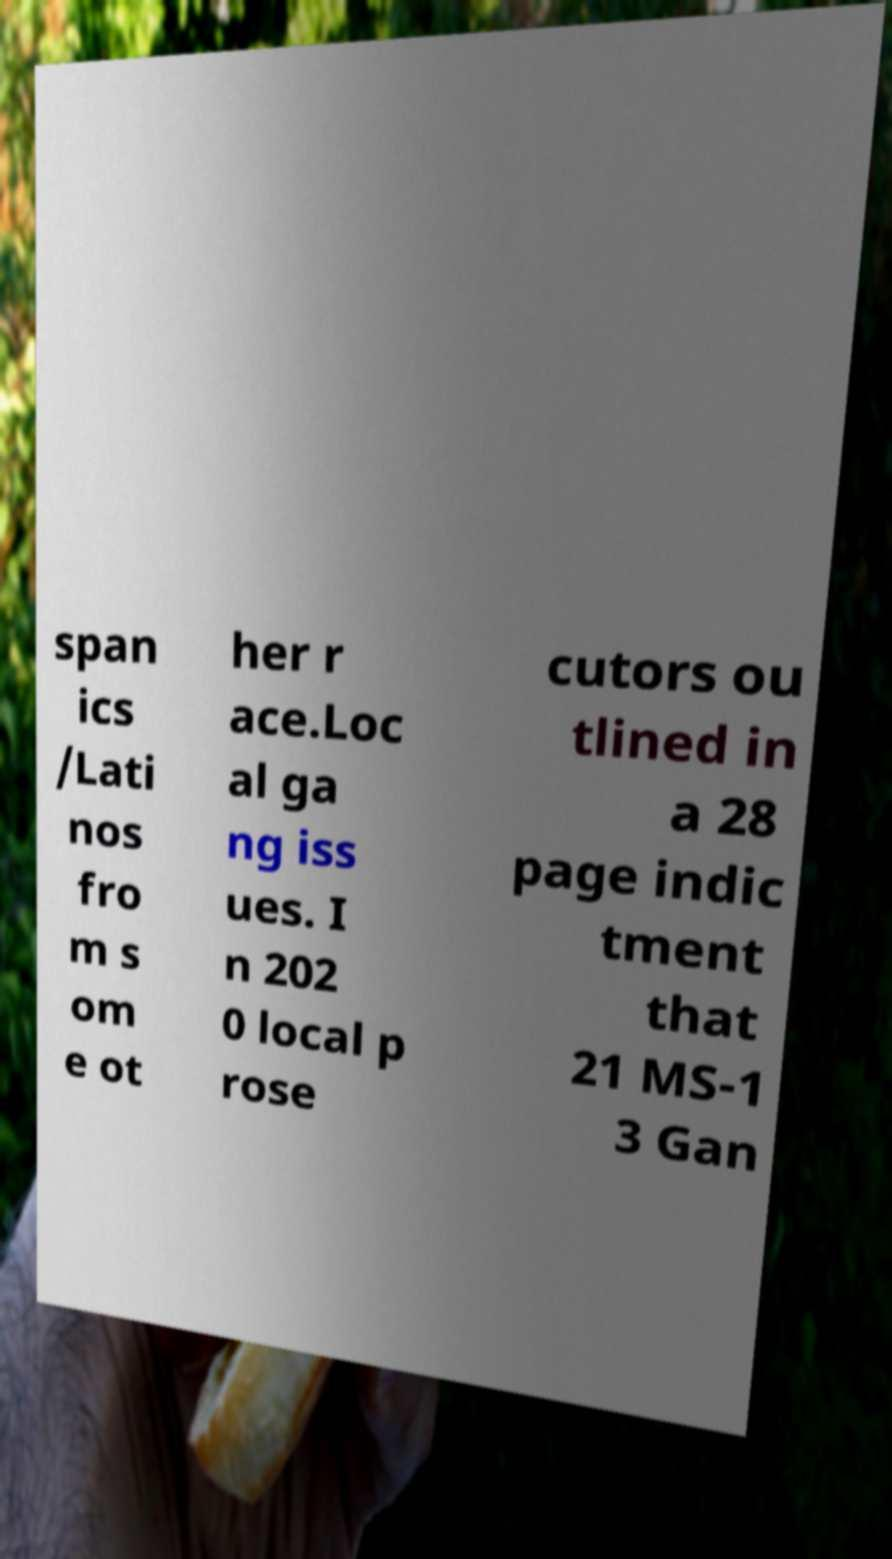For documentation purposes, I need the text within this image transcribed. Could you provide that? span ics /Lati nos fro m s om e ot her r ace.Loc al ga ng iss ues. I n 202 0 local p rose cutors ou tlined in a 28 page indic tment that 21 MS-1 3 Gan 